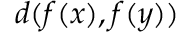<formula> <loc_0><loc_0><loc_500><loc_500>d ( f ( x ) , f ( y ) )</formula> 